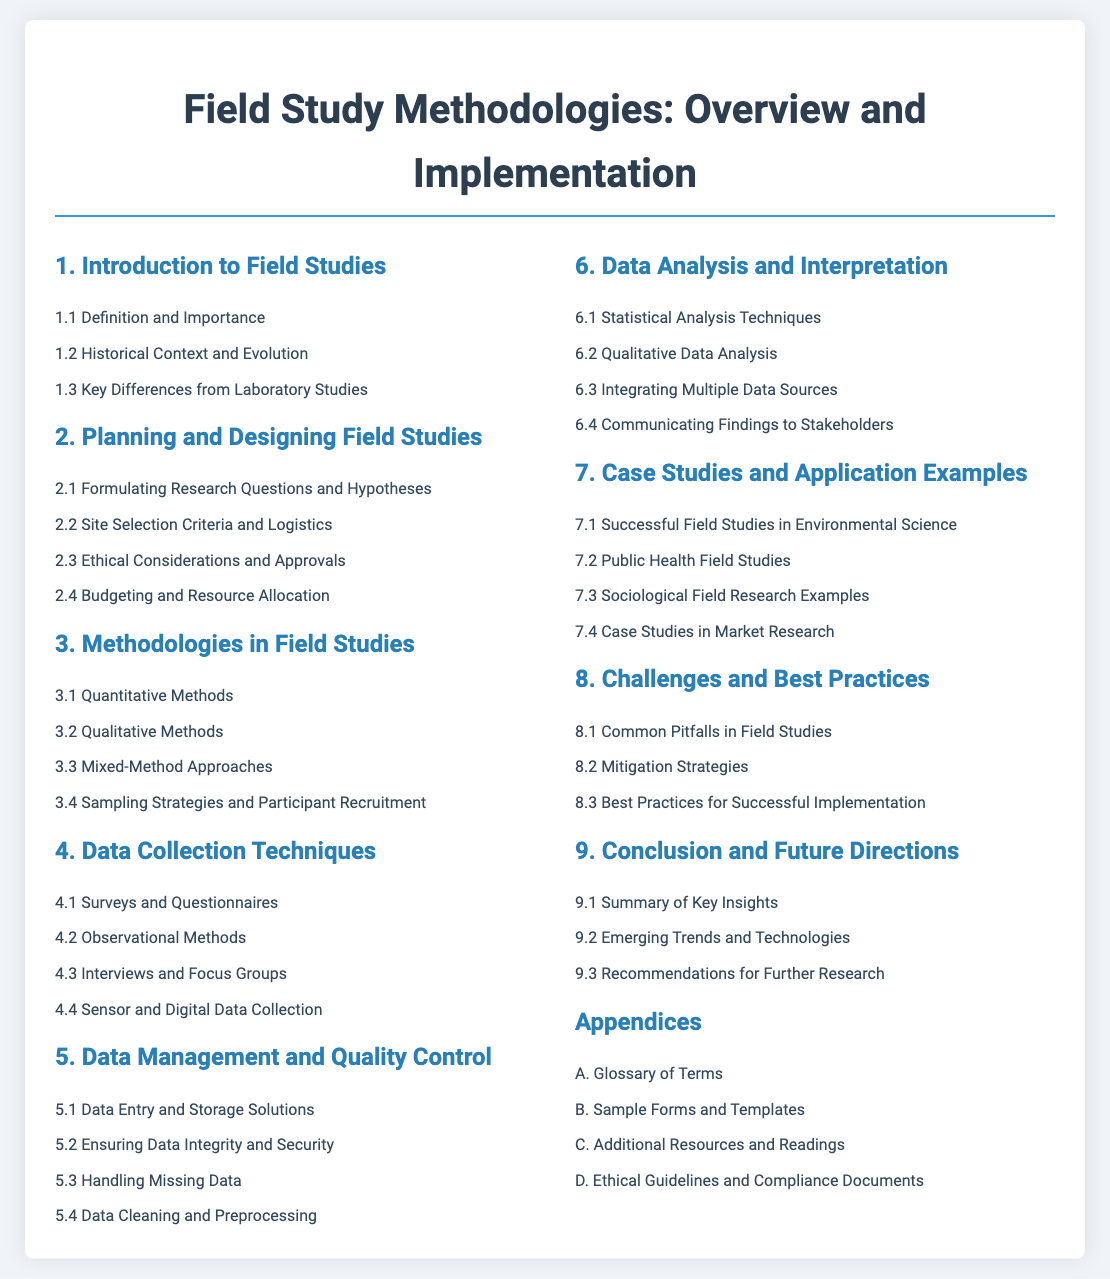what is the title of the document? The title of the document is stated at the top of the rendered content, serving as the main title.
Answer: Field Study Methodologies: Overview and Implementation how many sections are in the Table of Contents? The number of sections can be counted from the structured layout of the contents; there are nine main sections.
Answer: 9 which section covers ethical considerations? According to the structure, ethical considerations are specifically addressed within the planning and designing section of the studies.
Answer: 2.3 what are the two main types of methods outlined in the methodologies section? The methodologies section lists different approaches, with quantitative and qualitative being explicitly mentioned.
Answer: Quantitative Methods and Qualitative Methods what is the focus of section 6? Section 6 is devoted to the analysis and interpretation of data gathered from the field studies, as indicated by its title.
Answer: Data Analysis and Interpretation which case study area is mentioned first? The first area mentioned in the case studies section pertains to environmental science, highlighting successful applications in that field.
Answer: Successful Field Studies in Environmental Science what subsection includes data cleaning? The data cleaning topic is addressed in one of the subsections dedicated to data management and its quality maintenance.
Answer: 5.4 name one of the emerging trends suggested for future research. Future research directions mention the relevance of understanding and implementing new technologies in the field studies.
Answer: Emerging Trends and Technologies 